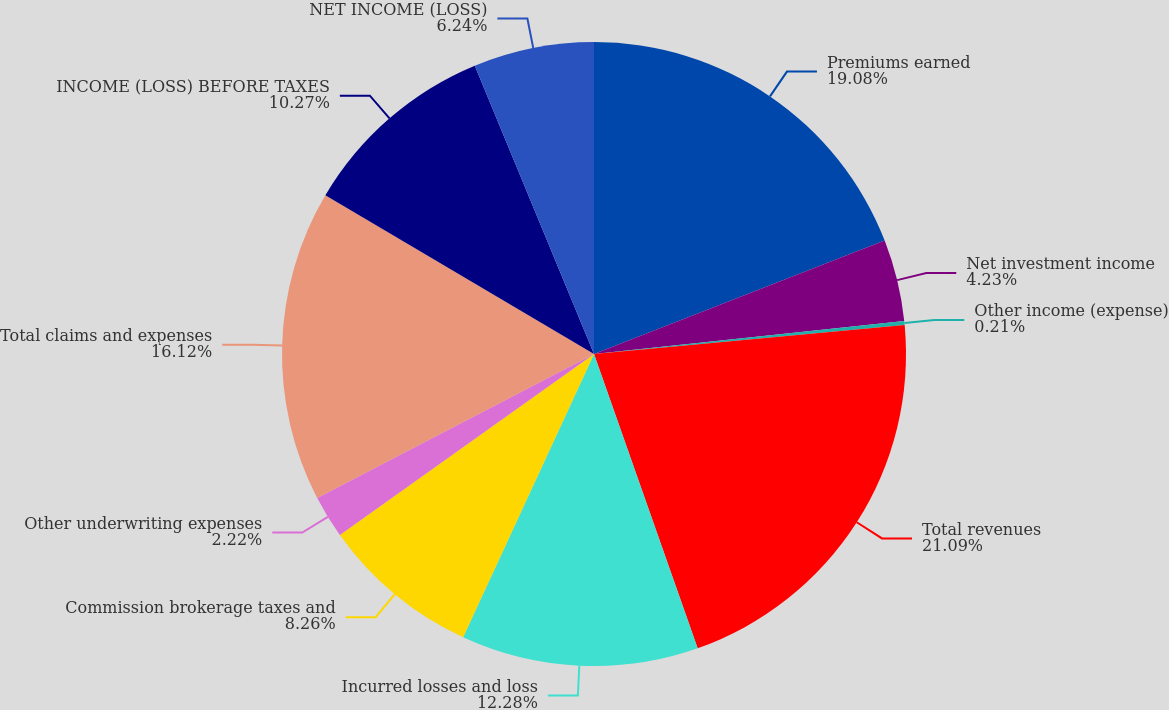<chart> <loc_0><loc_0><loc_500><loc_500><pie_chart><fcel>Premiums earned<fcel>Net investment income<fcel>Other income (expense)<fcel>Total revenues<fcel>Incurred losses and loss<fcel>Commission brokerage taxes and<fcel>Other underwriting expenses<fcel>Total claims and expenses<fcel>INCOME (LOSS) BEFORE TAXES<fcel>NET INCOME (LOSS)<nl><fcel>19.08%<fcel>4.23%<fcel>0.21%<fcel>21.09%<fcel>12.28%<fcel>8.26%<fcel>2.22%<fcel>16.12%<fcel>10.27%<fcel>6.24%<nl></chart> 